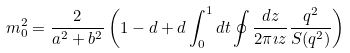<formula> <loc_0><loc_0><loc_500><loc_500>m _ { 0 } ^ { 2 } = \frac { 2 } { a ^ { 2 } + b ^ { 2 } } \left ( 1 - d + d \int _ { 0 } ^ { 1 } d t \oint \frac { d z } { 2 \pi \imath z } \frac { q ^ { 2 } } { S ( q ^ { 2 } ) } \right )</formula> 